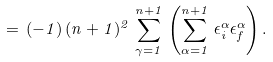Convert formula to latex. <formula><loc_0><loc_0><loc_500><loc_500>= \, ( - 1 ) \, ( n + 1 ) ^ { 2 } \, \sum _ { \gamma = 1 } ^ { n + 1 } \, \left ( \sum _ { \alpha = 1 } ^ { n + 1 } \, \epsilon _ { i } ^ { \alpha } \epsilon _ { f } ^ { \alpha } \right ) .</formula> 